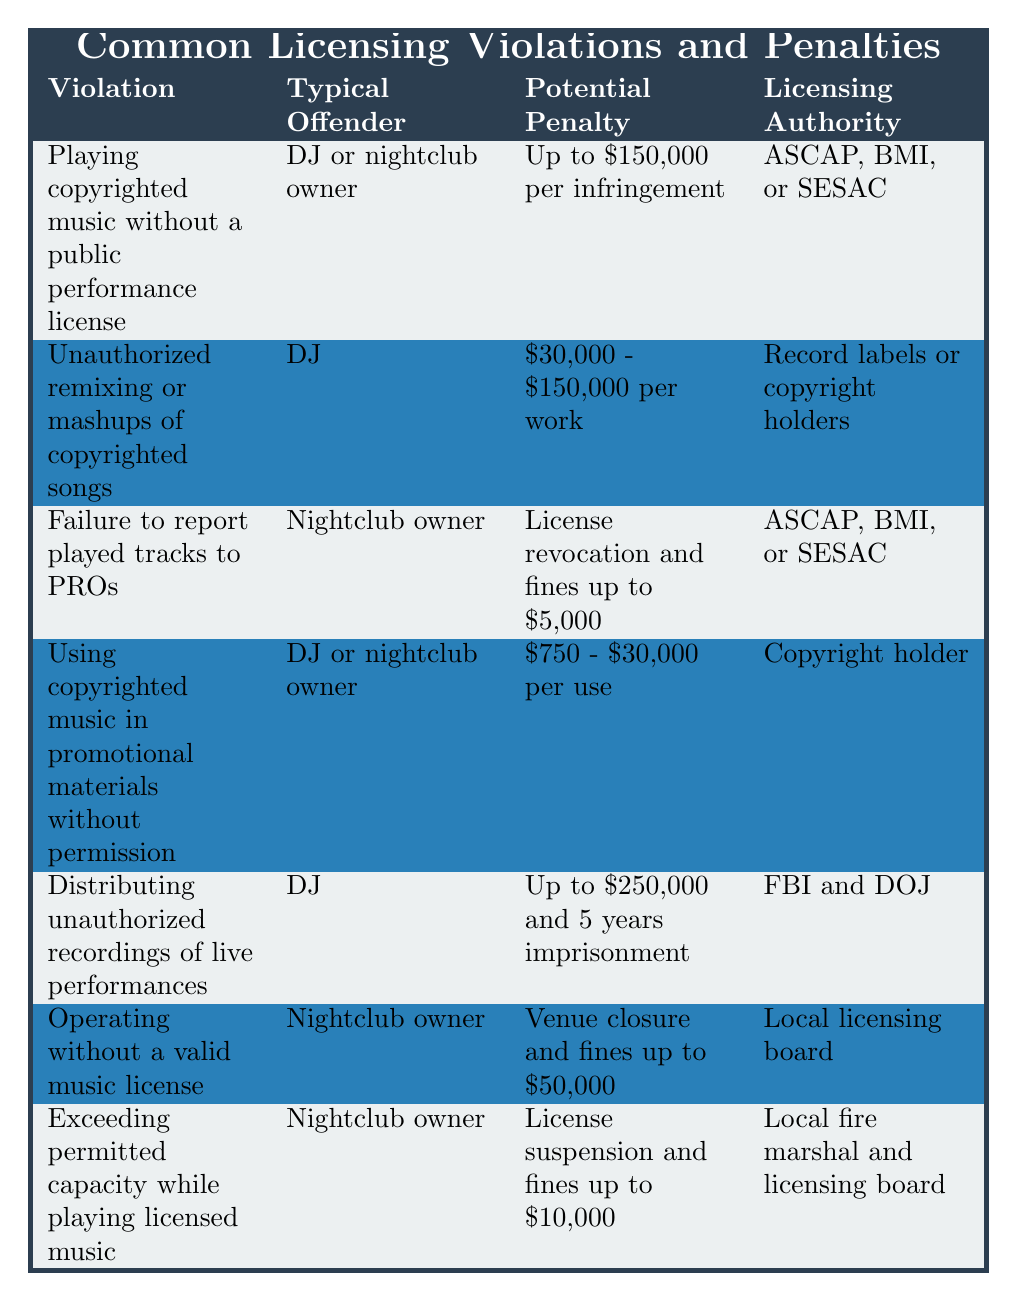What is the potential penalty for playing copyrighted music without a public performance license? The table states that the potential penalty for this violation is "Up to $150,000 per infringement."
Answer: Up to $150,000 per infringement Who is typically responsible for unauthorized remixing or mashups of copyrighted songs? According to the table, the typical offender for this violation is the "DJ."
Answer: DJ What could happen if a nightclub owner fails to report the tracks played to PROs? The potential penalty for failing to report played tracks is "License revocation and fines up to $5,000" according to the table.
Answer: License revocation and fines up to $5,000 Is it true that distributing unauthorized recordings of live performances can lead to imprisonment? Yes, the table indicates that this violation can lead to "Up to $250,000 and 5 years imprisonment."
Answer: Yes How much could a nightclub owner potentially face in fines for operating without a valid music license? The table states that the potential penalty is "Venue closure and fines up to $50,000."
Answer: Up to $50,000 in fines If a DJ uses copyrighted music in promotional materials without permission, what is the potential penalty? The table lists the potential penalty as "$750 - $30,000 per use."
Answer: $750 - $30,000 per use Which licensing authorities are associated with playing copyrighted music without a public performance license? The table lists "ASCAP, BMI, or SESAC" as the licensing authorities for this violation.
Answer: ASCAP, BMI, or SESAC What is the total penalty range for unauthorized remixing or mashups of copyrighted songs? The penalty range mentioned in the table is "$30,000 - $150,000 per work."
Answer: $30,000 - $150,000 per work Are nightclub owners liable for fines if they exceed the permitted capacity while playing licensed music? Yes, according to the table, they face "License suspension and fines up to $10,000."
Answer: Yes What is the difference in potential penalties between unauthorized remixing and distributing unauthorized recordings of live performances? Unauthorized remixing has a potential penalty range of "$30,000 - $150,000," while distributing unauthorized recordings has a penalty of "Up to $250,000 and 5 years imprisonment." Thus, the difference is significant.
Answer: Distributing has higher penalties 